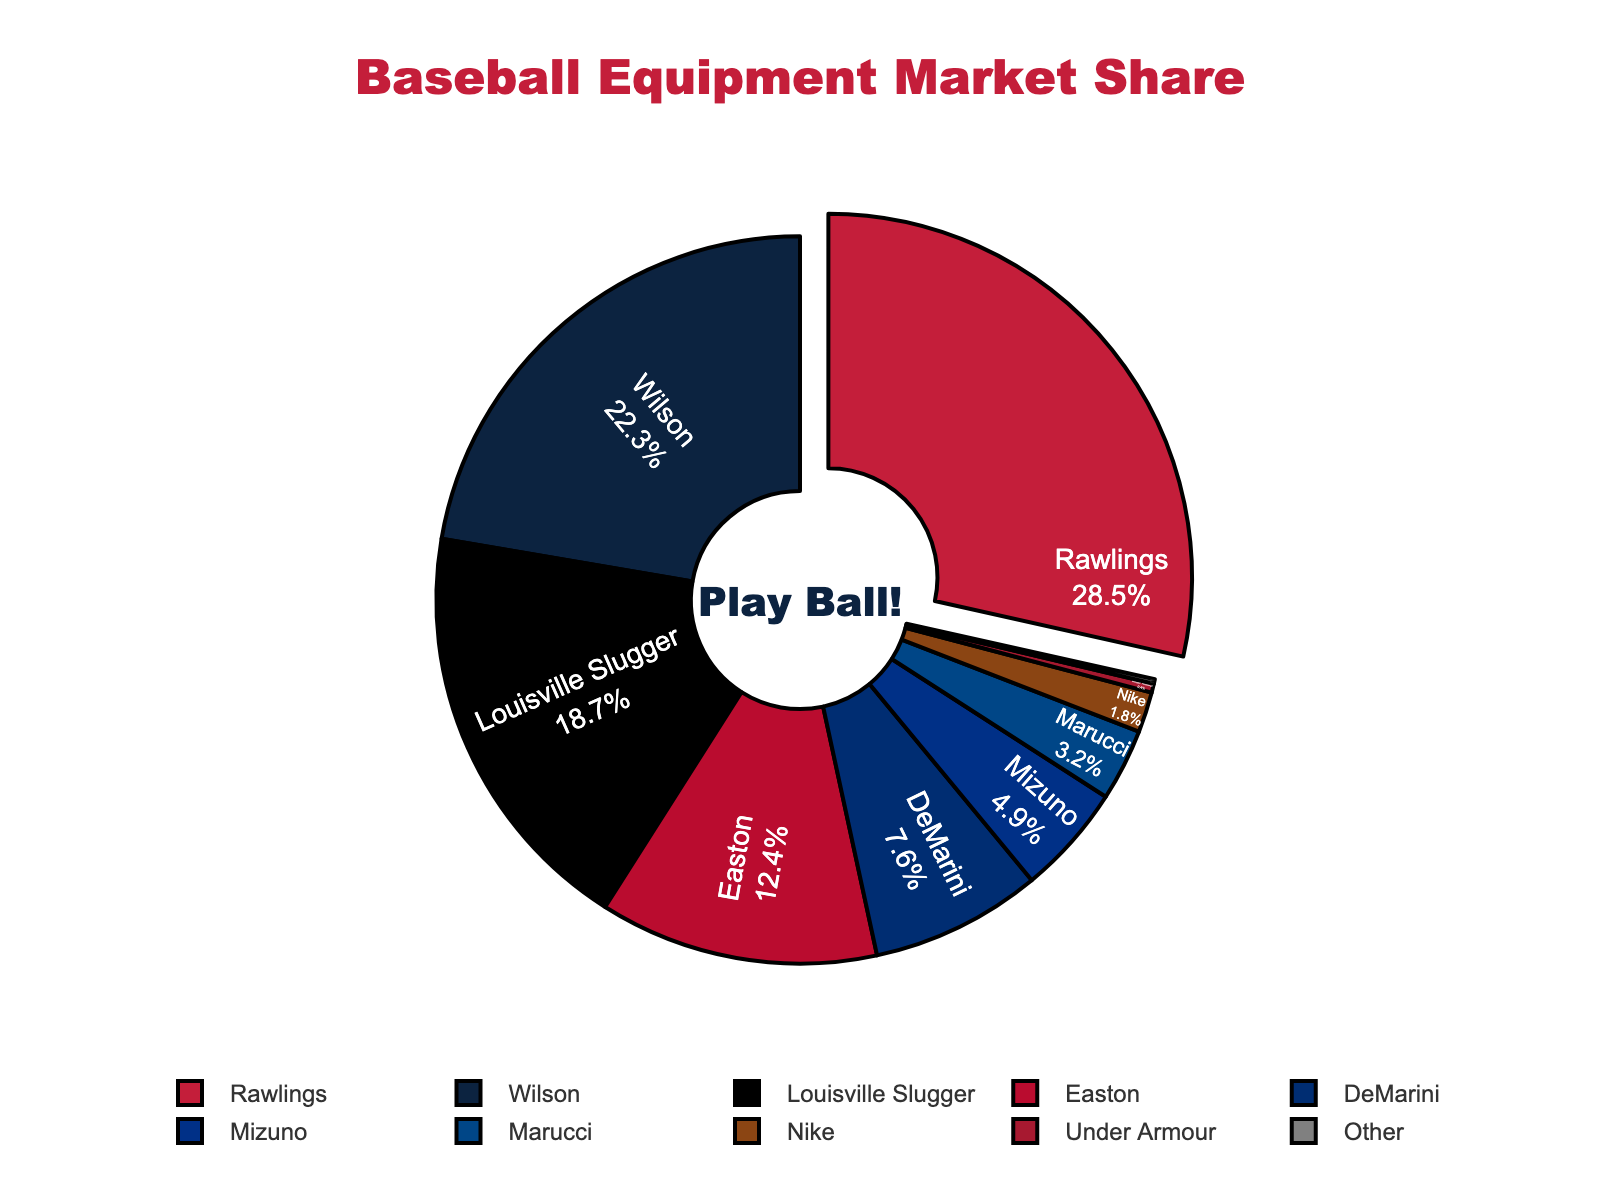Which company has the largest market share? The largest segment in the pie chart is pulled out and labeled "Rawlings" with a 28.5% market share.
Answer: Rawlings What is the combined market share of Easton and Louisville Slugger? Easton has a market share of 12.4% and Louisville Slugger has 18.7%. Summing these two percentages gives 12.4 + 18.7 = 31.1%.
Answer: 31.1% Which manufacturers have a market share of less than 5%? The segments representing Mizuno (4.9%), Marucci (3.2%), Nike (1.8%), Under Armour (0.4%), and Other (0.2%) all have market shares less than 5%.
Answer: Mizuno, Marucci, Nike, Under Armour, Other Is Wilson's market share greater than that of DeMarini? Wilson has a market share of 22.3%, which is greater than DeMarini's 7.6%.
Answer: Yes What's the difference in market share between the top two companies? Rawlings has a 28.5% market share and Wilson has 22.3%. The difference is 28.5 - 22.3 = 6.2%.
Answer: 6.2% Which company has the smallest proportion of the market, and what is the value? The "Other" segment is the smallest on the chart with a market share of 0.2%.
Answer: Other, 0.2% How does Nike's market share compare to that of Marucci? Nike has a market share of 1.8%, while Marucci has 3.2%. Nike's share is smaller.
Answer: Nike's share is smaller What combined market share do Rawlings, Wilson, and Louisville Slugger hold? Summing the market shares of Rawlings (28.5%), Wilson (22.3%), and Louisville Slugger (18.7%), we get 28.5 + 22.3 + 18.7 = 69.5%.
Answer: 69.5% Which company has a market share closest to 10%? Among the given options, Easton with 12.4% is the closest to 10%.
Answer: Easton What market share would Rawlings have if its share were increased by 5%? Adding 5% to Rawlings' 28.5% market share gives 28.5 + 5 = 33.5%.
Answer: 33.5% 